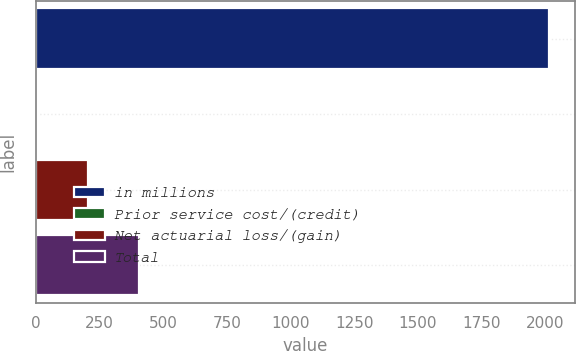<chart> <loc_0><loc_0><loc_500><loc_500><bar_chart><fcel>in millions<fcel>Prior service cost/(credit)<fcel>Net actuarial loss/(gain)<fcel>Total<nl><fcel>2017<fcel>3.9<fcel>205.21<fcel>406.52<nl></chart> 